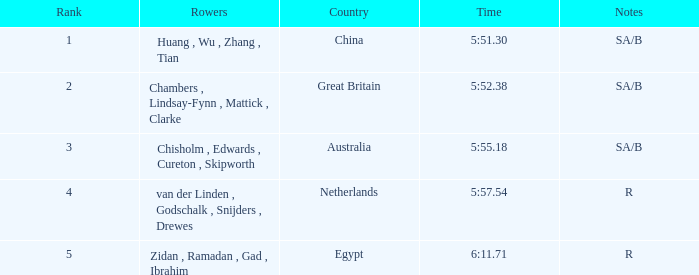30? Huang , Wu , Zhang , Tian. 